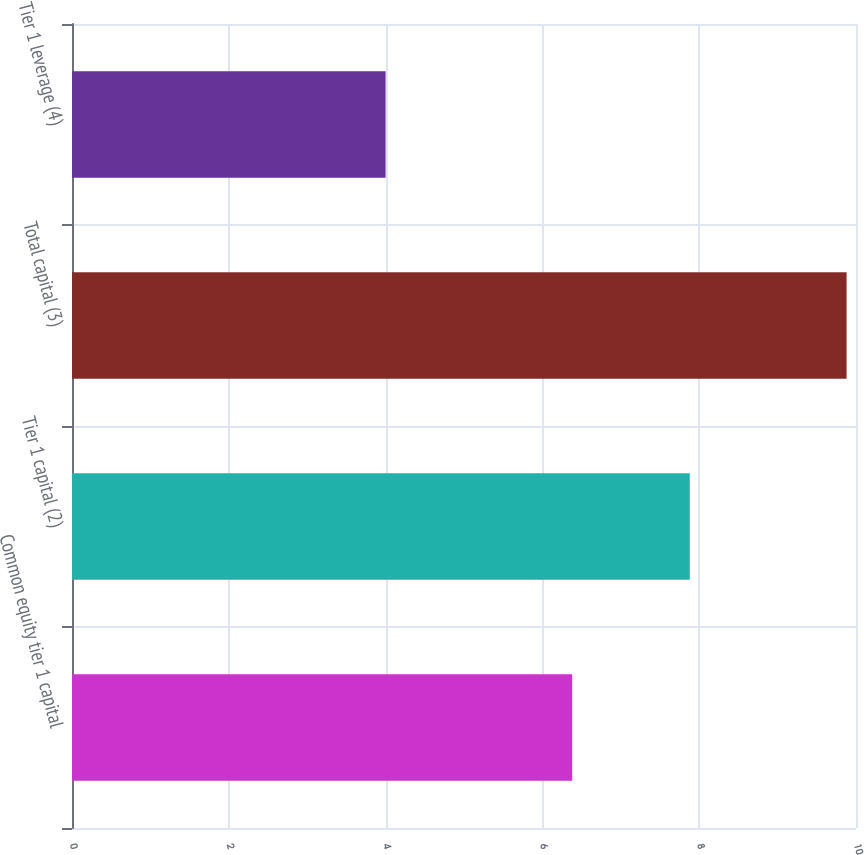Convert chart to OTSL. <chart><loc_0><loc_0><loc_500><loc_500><bar_chart><fcel>Common equity tier 1 capital<fcel>Tier 1 capital (2)<fcel>Total capital (3)<fcel>Tier 1 leverage (4)<nl><fcel>6.38<fcel>7.88<fcel>9.88<fcel>4<nl></chart> 